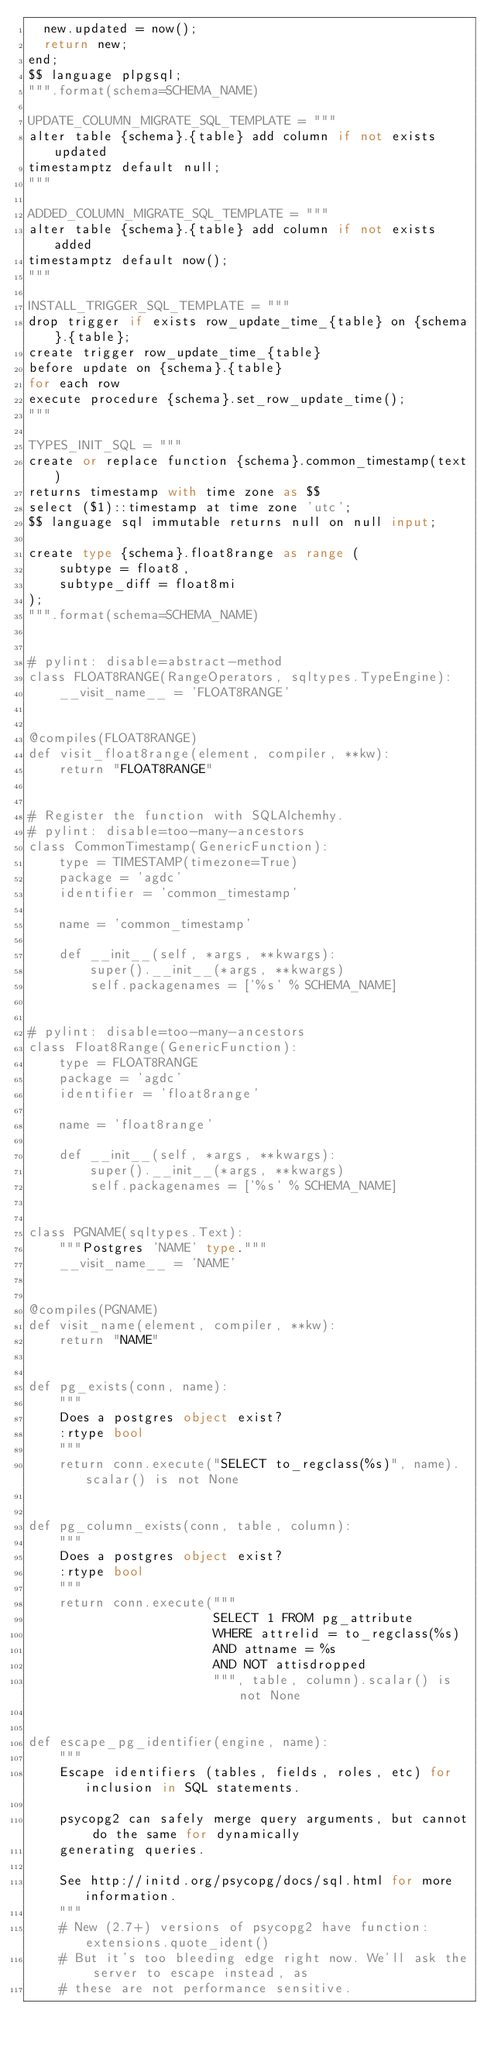Convert code to text. <code><loc_0><loc_0><loc_500><loc_500><_Python_>  new.updated = now();
  return new;
end;
$$ language plpgsql;
""".format(schema=SCHEMA_NAME)

UPDATE_COLUMN_MIGRATE_SQL_TEMPLATE = """
alter table {schema}.{table} add column if not exists updated
timestamptz default null;
"""

ADDED_COLUMN_MIGRATE_SQL_TEMPLATE = """
alter table {schema}.{table} add column if not exists added
timestamptz default now();
"""

INSTALL_TRIGGER_SQL_TEMPLATE = """
drop trigger if exists row_update_time_{table} on {schema}.{table};
create trigger row_update_time_{table}
before update on {schema}.{table}
for each row
execute procedure {schema}.set_row_update_time();
"""

TYPES_INIT_SQL = """
create or replace function {schema}.common_timestamp(text)
returns timestamp with time zone as $$
select ($1)::timestamp at time zone 'utc';
$$ language sql immutable returns null on null input;

create type {schema}.float8range as range (
    subtype = float8,
    subtype_diff = float8mi
);
""".format(schema=SCHEMA_NAME)


# pylint: disable=abstract-method
class FLOAT8RANGE(RangeOperators, sqltypes.TypeEngine):
    __visit_name__ = 'FLOAT8RANGE'


@compiles(FLOAT8RANGE)
def visit_float8range(element, compiler, **kw):
    return "FLOAT8RANGE"


# Register the function with SQLAlchemhy.
# pylint: disable=too-many-ancestors
class CommonTimestamp(GenericFunction):
    type = TIMESTAMP(timezone=True)
    package = 'agdc'
    identifier = 'common_timestamp'

    name = 'common_timestamp'

    def __init__(self, *args, **kwargs):
        super().__init__(*args, **kwargs)
        self.packagenames = ['%s' % SCHEMA_NAME]


# pylint: disable=too-many-ancestors
class Float8Range(GenericFunction):
    type = FLOAT8RANGE
    package = 'agdc'
    identifier = 'float8range'

    name = 'float8range'

    def __init__(self, *args, **kwargs):
        super().__init__(*args, **kwargs)
        self.packagenames = ['%s' % SCHEMA_NAME]


class PGNAME(sqltypes.Text):
    """Postgres 'NAME' type."""
    __visit_name__ = 'NAME'


@compiles(PGNAME)
def visit_name(element, compiler, **kw):
    return "NAME"


def pg_exists(conn, name):
    """
    Does a postgres object exist?
    :rtype bool
    """
    return conn.execute("SELECT to_regclass(%s)", name).scalar() is not None


def pg_column_exists(conn, table, column):
    """
    Does a postgres object exist?
    :rtype bool
    """
    return conn.execute("""
                        SELECT 1 FROM pg_attribute
                        WHERE attrelid = to_regclass(%s)
                        AND attname = %s
                        AND NOT attisdropped
                        """, table, column).scalar() is not None


def escape_pg_identifier(engine, name):
    """
    Escape identifiers (tables, fields, roles, etc) for inclusion in SQL statements.

    psycopg2 can safely merge query arguments, but cannot do the same for dynamically
    generating queries.

    See http://initd.org/psycopg/docs/sql.html for more information.
    """
    # New (2.7+) versions of psycopg2 have function: extensions.quote_ident()
    # But it's too bleeding edge right now. We'll ask the server to escape instead, as
    # these are not performance sensitive.</code> 